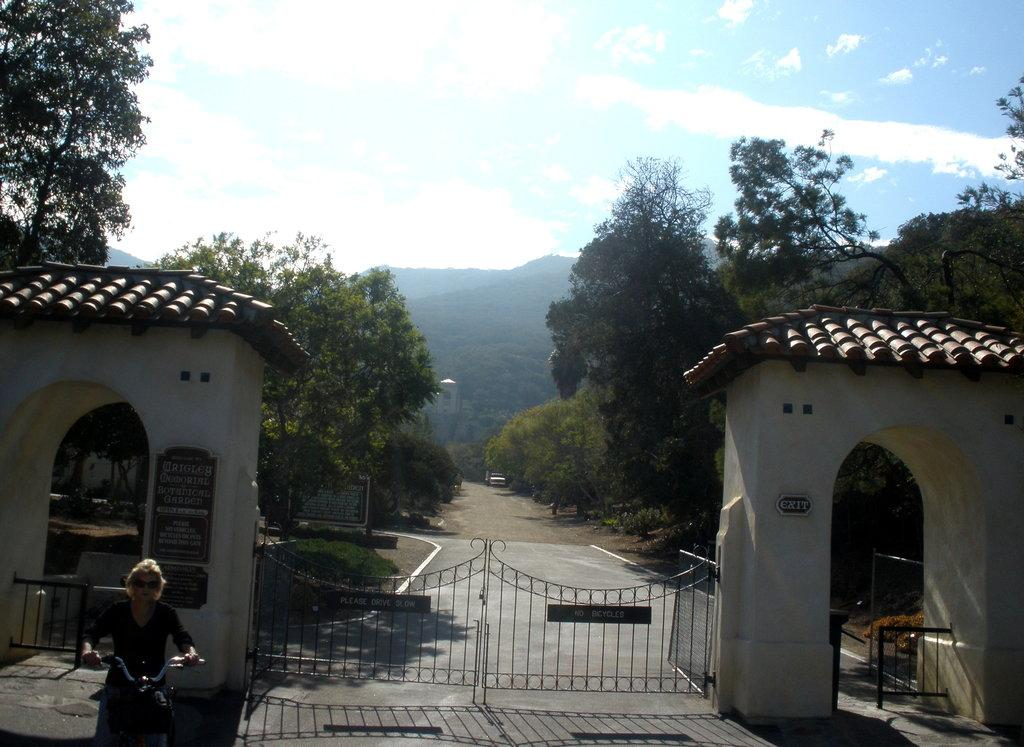What type of natural elements can be seen in the image? There are trees and hills visible in the image. What type of structures are present in the image? There are gates and arches in the image. What type of objects can be seen on the ground in the image? There are boards in the image. What is the person in the image doing? A person is riding a bicycle at the bottom left corner of the image. What is visible in the background of the image? The sky is visible in the background of the image. What type of skin condition can be seen on the trees in the image? There is no mention of any skin condition on the trees in the image. Are there any jellyfish visible in the image? There are no jellyfish present in the image. 